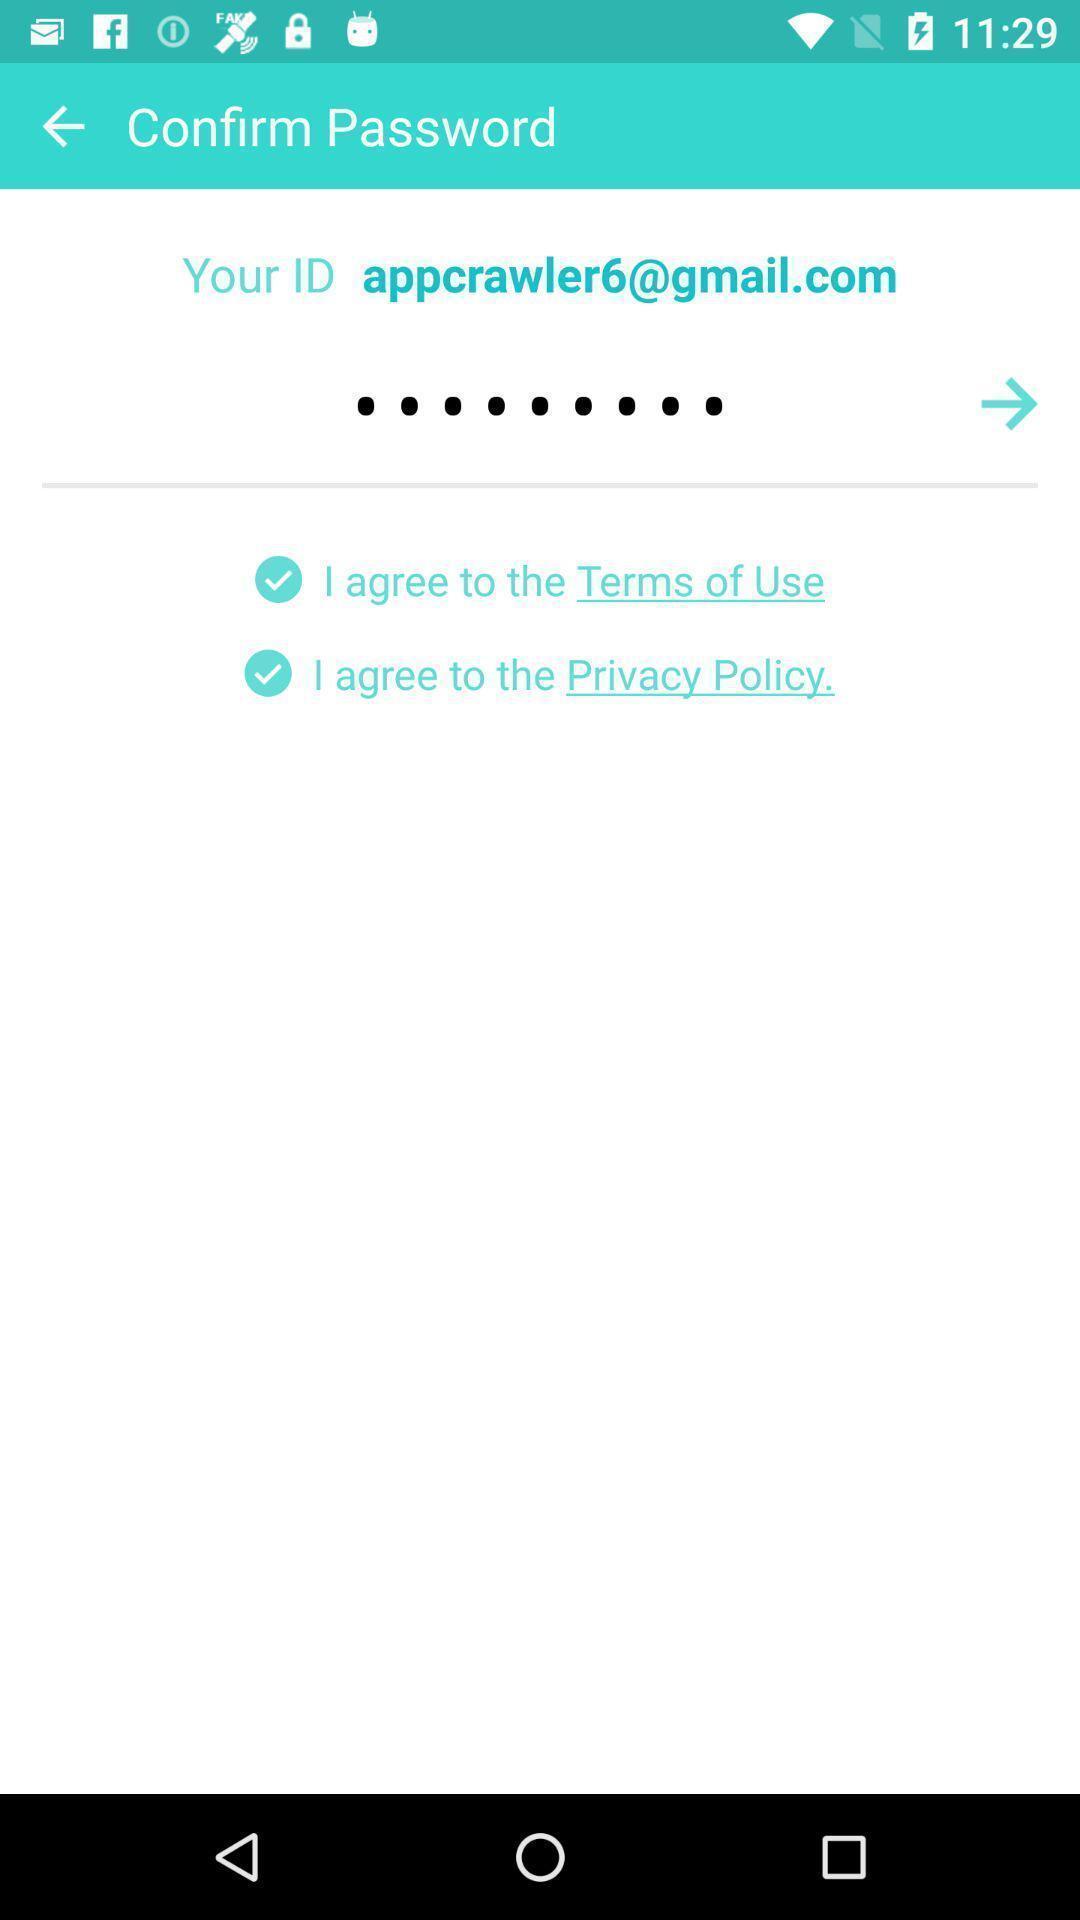Please provide a description for this image. Page requesting to confirm the password. 